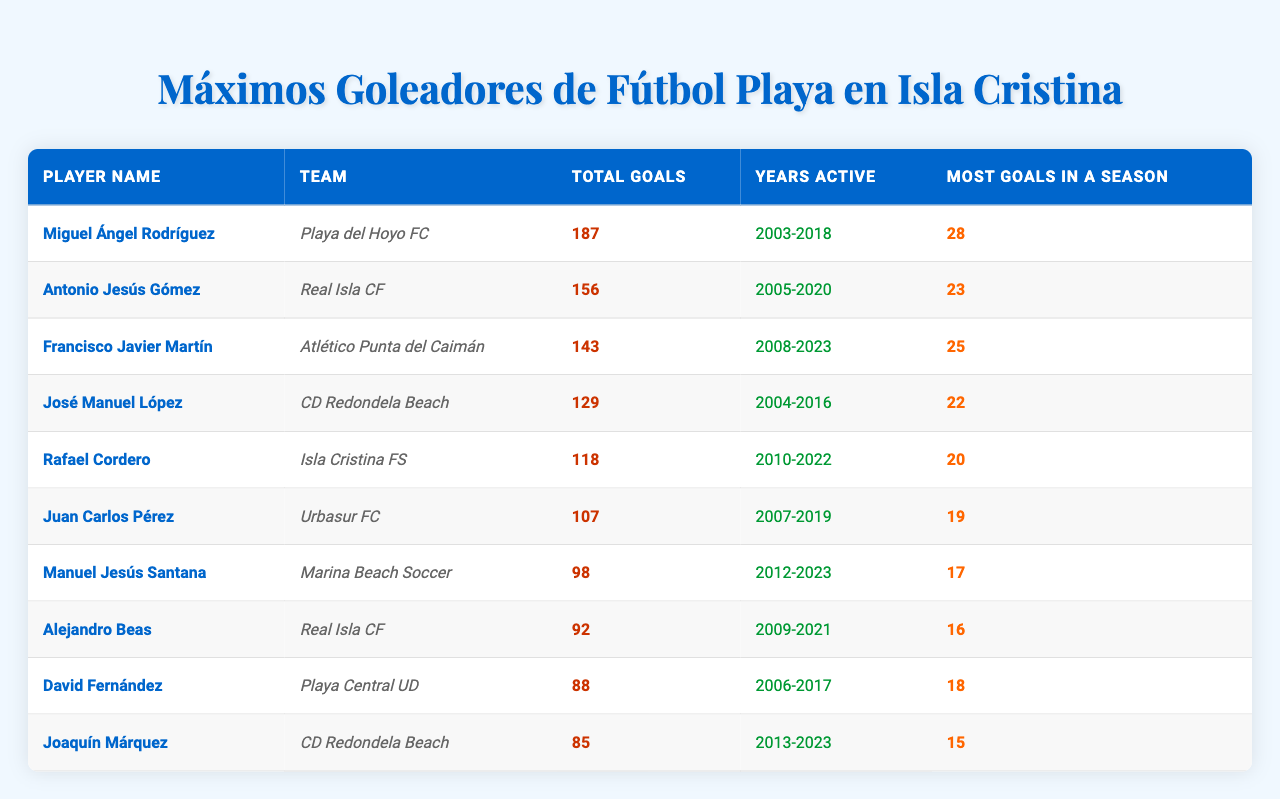What is the total number of goals scored by Miguel Ángel Rodríguez? Miguel Ángel Rodríguez's total goals are listed in the table under "Total Goals," which shows he has scored 187 goals.
Answer: 187 Which player has the most goals in a single season? The table indicates that Miguel Ángel Rodríguez scored the most goals in a season, with a total of 28.
Answer: Miguel Ángel Rodríguez What is the average number of goals scored by the top three players? To find the average, sum the total goals of the top three players (187 + 156 + 143 = 486) and divide by 3. The average is 486 / 3 = 162.
Answer: 162 Did Antonio Jesús Gómez play more years than José Manuel López? Antonio Jesús Gómez was active from 2005 to 2020, totaling 16 years, while José Manuel López was active from 2004 to 2016, totaling 13 years. Thus, the statement is true.
Answer: Yes Which player has the highest total goals and their team? Miguel Ángel Rodríguez has the highest total goals at 187, and he played for Playa del Hoyo FC.
Answer: Miguel Ángel Rodríguez, Playa del Hoyo FC How many total goals did players from Real Isla CF score? From the table, the total goals for players from Real Isla CF are by Antonio Jesús Gómez (156) and Alejandro Beas (92). Summing these gives 156 + 92 = 248.
Answer: 248 Which player scored the least and how many total goals did they have? The player with the least total goals in the table is Joaquín Márquez, who scored 85 goals.
Answer: Joaquín Márquez, 85 What is the difference between the total goals scored by Rafael Cordero and Juan Carlos Pérez? Rafael Cordero scored 118 goals and Juan Carlos Pérez scored 107 goals. The difference is 118 - 107 = 11.
Answer: 11 How many players scored more than 100 goals? In the table, the players who scored more than 100 goals are Miguel Ángel Rodríguez, Antonio Jesús Gómez, Francisco Javier Martín, José Manuel López, Rafael Cordero, and Juan Carlos Pérez. That makes a total of 6 players.
Answer: 6 Which team had the player with the most goals and what is the player's name? Playa del Hoyo FC had the player with the most goals, Miguel Ángel Rodríguez, who scored 187 goals.
Answer: Playa del Hoyo FC, Miguel Ángel Rodríguez 